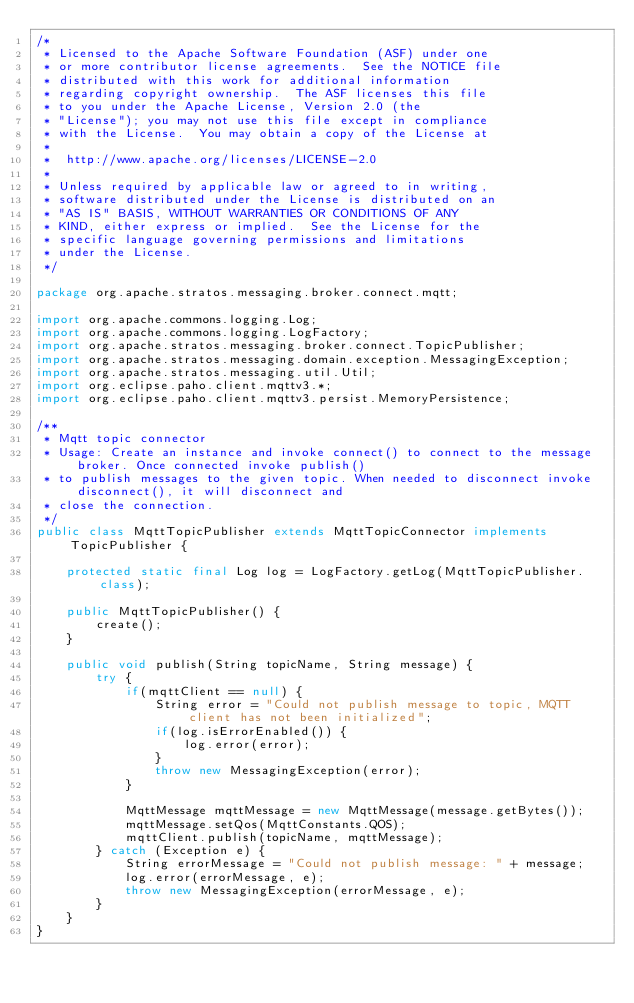<code> <loc_0><loc_0><loc_500><loc_500><_Java_>/*
 * Licensed to the Apache Software Foundation (ASF) under one
 * or more contributor license agreements.  See the NOTICE file
 * distributed with this work for additional information
 * regarding copyright ownership.  The ASF licenses this file
 * to you under the Apache License, Version 2.0 (the
 * "License"); you may not use this file except in compliance
 * with the License.  You may obtain a copy of the License at
 *
 *  http://www.apache.org/licenses/LICENSE-2.0
 *
 * Unless required by applicable law or agreed to in writing,
 * software distributed under the License is distributed on an
 * "AS IS" BASIS, WITHOUT WARRANTIES OR CONDITIONS OF ANY
 * KIND, either express or implied.  See the License for the
 * specific language governing permissions and limitations
 * under the License.
 */

package org.apache.stratos.messaging.broker.connect.mqtt;

import org.apache.commons.logging.Log;
import org.apache.commons.logging.LogFactory;
import org.apache.stratos.messaging.broker.connect.TopicPublisher;
import org.apache.stratos.messaging.domain.exception.MessagingException;
import org.apache.stratos.messaging.util.Util;
import org.eclipse.paho.client.mqttv3.*;
import org.eclipse.paho.client.mqttv3.persist.MemoryPersistence;

/**
 * Mqtt topic connector
 * Usage: Create an instance and invoke connect() to connect to the message broker. Once connected invoke publish()
 * to publish messages to the given topic. When needed to disconnect invoke disconnect(), it will disconnect and
 * close the connection.
 */
public class MqttTopicPublisher extends MqttTopicConnector implements TopicPublisher {

    protected static final Log log = LogFactory.getLog(MqttTopicPublisher.class);

    public MqttTopicPublisher() {
        create();
    }

    public void publish(String topicName, String message) {
        try {
            if(mqttClient == null) {
                String error = "Could not publish message to topic, MQTT client has not been initialized";
                if(log.isErrorEnabled()) {
                    log.error(error);
                }
                throw new MessagingException(error);
            }

            MqttMessage mqttMessage = new MqttMessage(message.getBytes());
            mqttMessage.setQos(MqttConstants.QOS);
            mqttClient.publish(topicName, mqttMessage);
        } catch (Exception e) {
            String errorMessage = "Could not publish message: " + message;
            log.error(errorMessage, e);
            throw new MessagingException(errorMessage, e);
        }
    }
}
</code> 